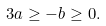<formula> <loc_0><loc_0><loc_500><loc_500>3 a \geq - b \geq 0 .</formula> 